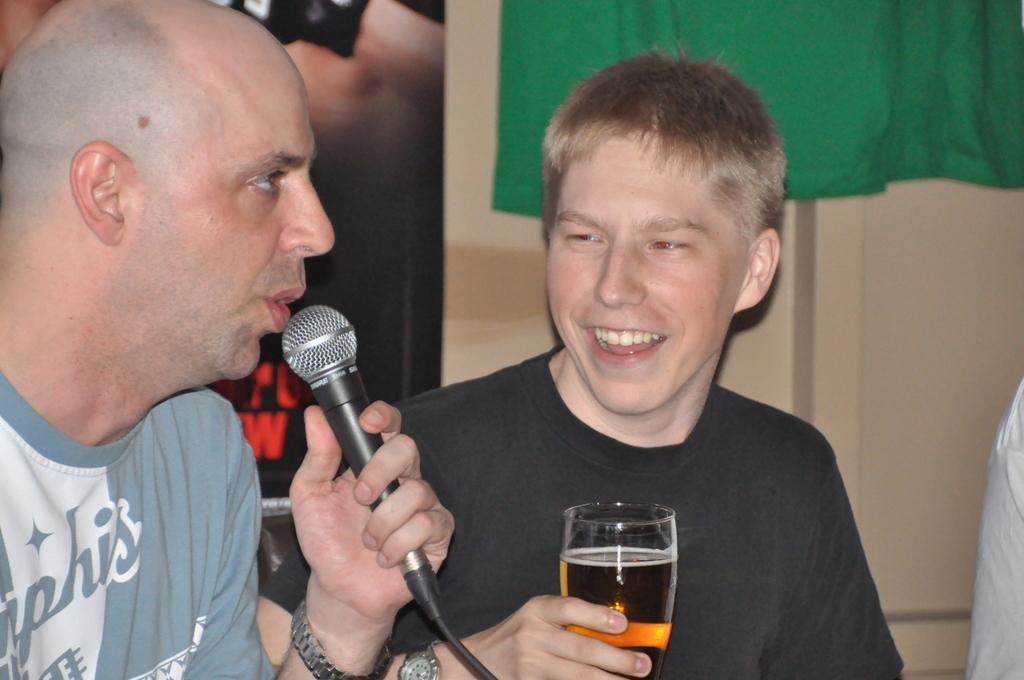Describe this image in one or two sentences. In the image we can see there is a man who is sitting and holding mic in his hand and another man is holding wine glass in his hand. 